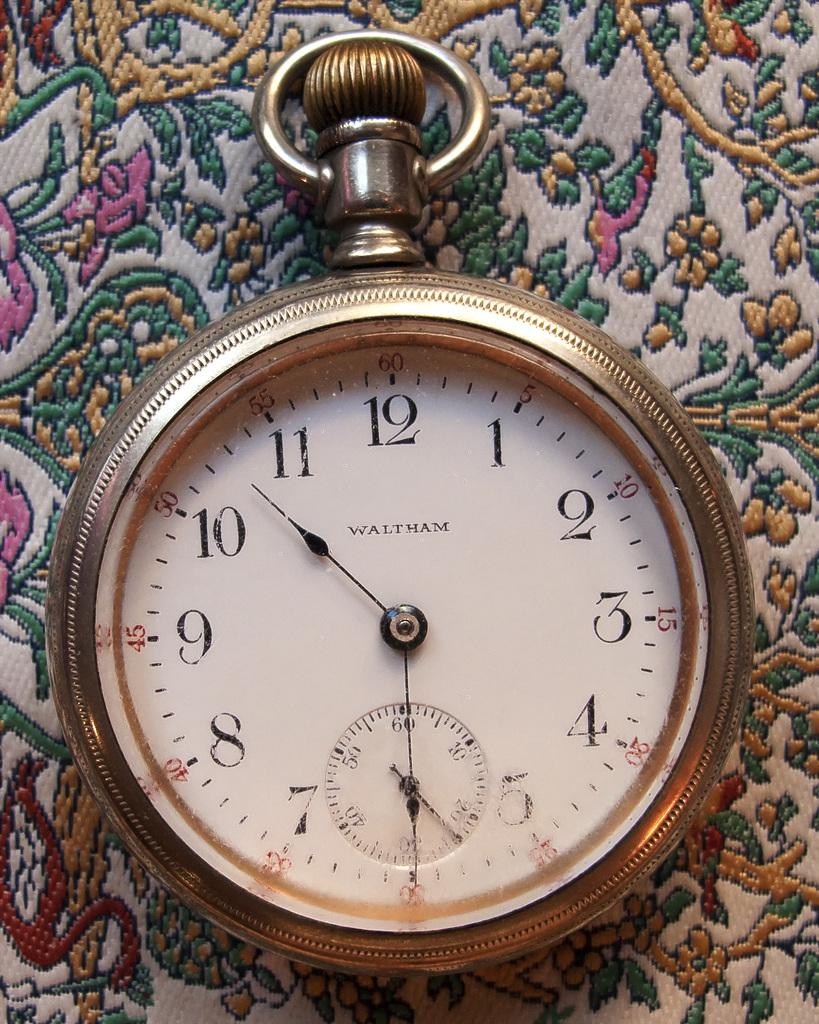<image>
Render a clear and concise summary of the photo. A pocketwatch by the brand Waltham displays the time 10:30. 